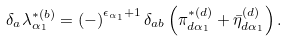<formula> <loc_0><loc_0><loc_500><loc_500>\delta _ { a } \lambda _ { \alpha _ { 1 } } ^ { * ( b ) } = \left ( - \right ) ^ { \epsilon _ { \alpha _ { 1 } } + 1 } \delta _ { a b } \left ( \pi _ { d \alpha _ { 1 } } ^ { * ( d ) } + \bar { \eta } _ { d \alpha _ { 1 } } ^ { ( d ) } \right ) .</formula> 